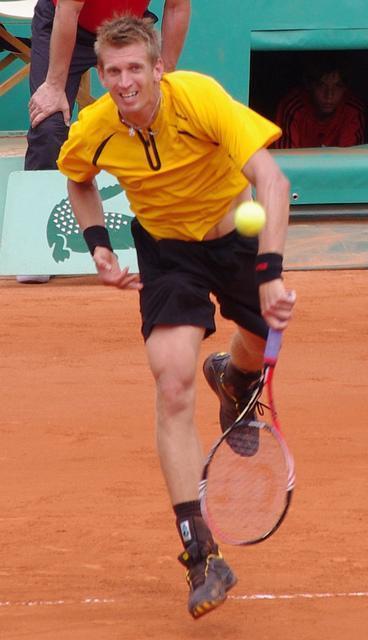How many people are there?
Give a very brief answer. 2. How many people are in the photo?
Give a very brief answer. 3. How many tennis rackets are there?
Give a very brief answer. 1. 